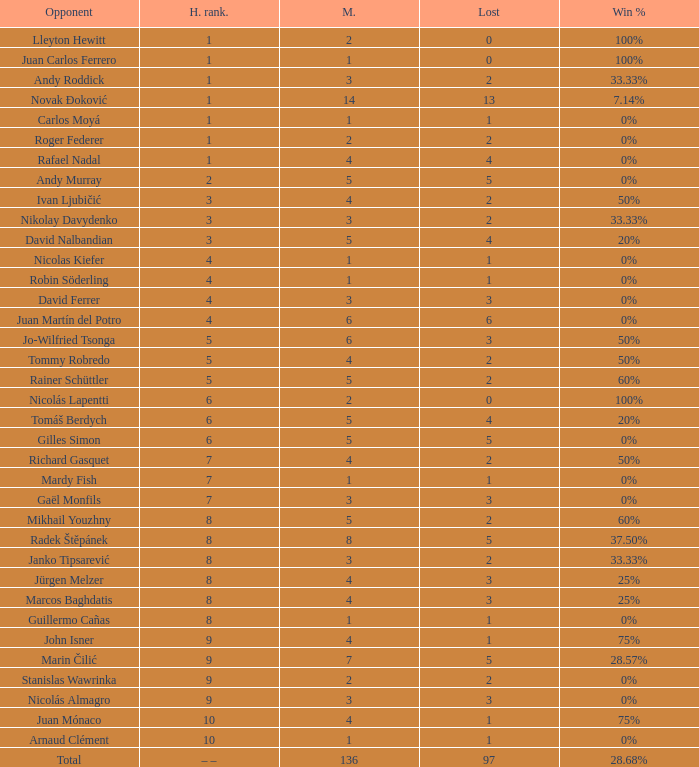What is the smallest number of Matches with less than 97 losses and a Win rate of 28.68%? None. 